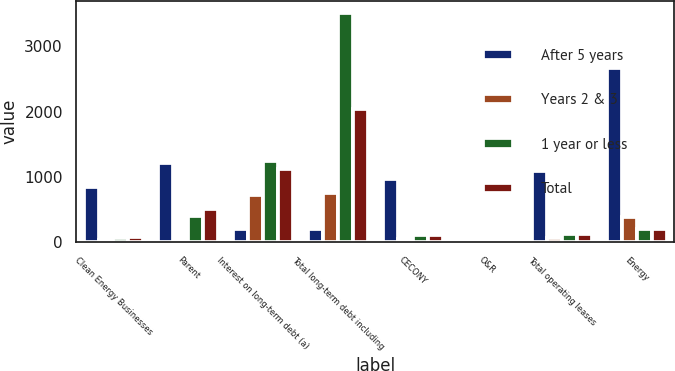<chart> <loc_0><loc_0><loc_500><loc_500><stacked_bar_chart><ecel><fcel>Clean Energy Businesses<fcel>Parent<fcel>Interest on long-term debt (a)<fcel>Total long-term debt including<fcel>CECONY<fcel>O&R<fcel>Total operating leases<fcel>Energy<nl><fcel>After 5 years<fcel>845<fcel>1206<fcel>202<fcel>202<fcel>964<fcel>5<fcel>1091<fcel>2661<nl><fcel>Years 2 & 3<fcel>33<fcel>2<fcel>719<fcel>758<fcel>53<fcel>1<fcel>61<fcel>390<nl><fcel>1 year or less<fcel>65<fcel>405<fcel>1251<fcel>3513<fcel>108<fcel>2<fcel>123<fcel>202<nl><fcel>Total<fcel>72<fcel>506<fcel>1115<fcel>2043<fcel>107<fcel>1<fcel>119<fcel>202<nl></chart> 